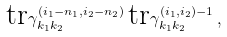Convert formula to latex. <formula><loc_0><loc_0><loc_500><loc_500>\text {tr} \gamma ^ { ( i _ { 1 } - n _ { 1 } , i _ { 2 } - n _ { 2 } ) } _ { k _ { 1 } k _ { 2 } } \, \text {tr} \gamma ^ { ( i _ { 1 } , i _ { 2 } ) - 1 } _ { k _ { 1 } k _ { 2 } } \, ,</formula> 